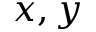<formula> <loc_0><loc_0><loc_500><loc_500>x , y</formula> 